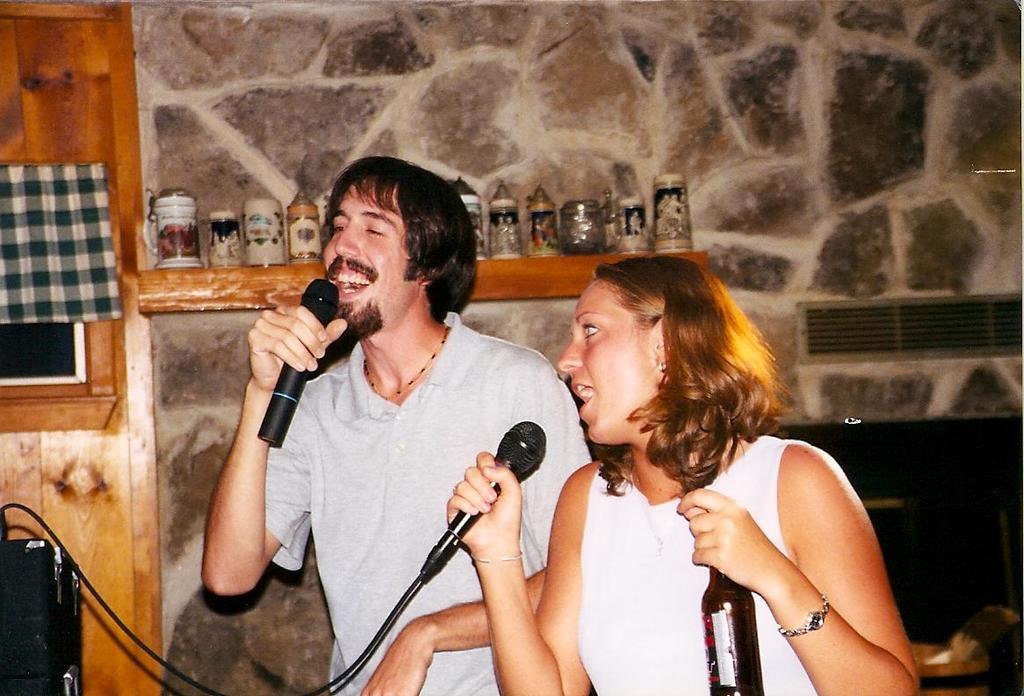Can you describe this image briefly? In this image we can see two persons, they are holding mics, one of them is holding a bottle, there is a speaker, there is a cloth, and the door, also we can see the air conditioner grille, and the wall. 